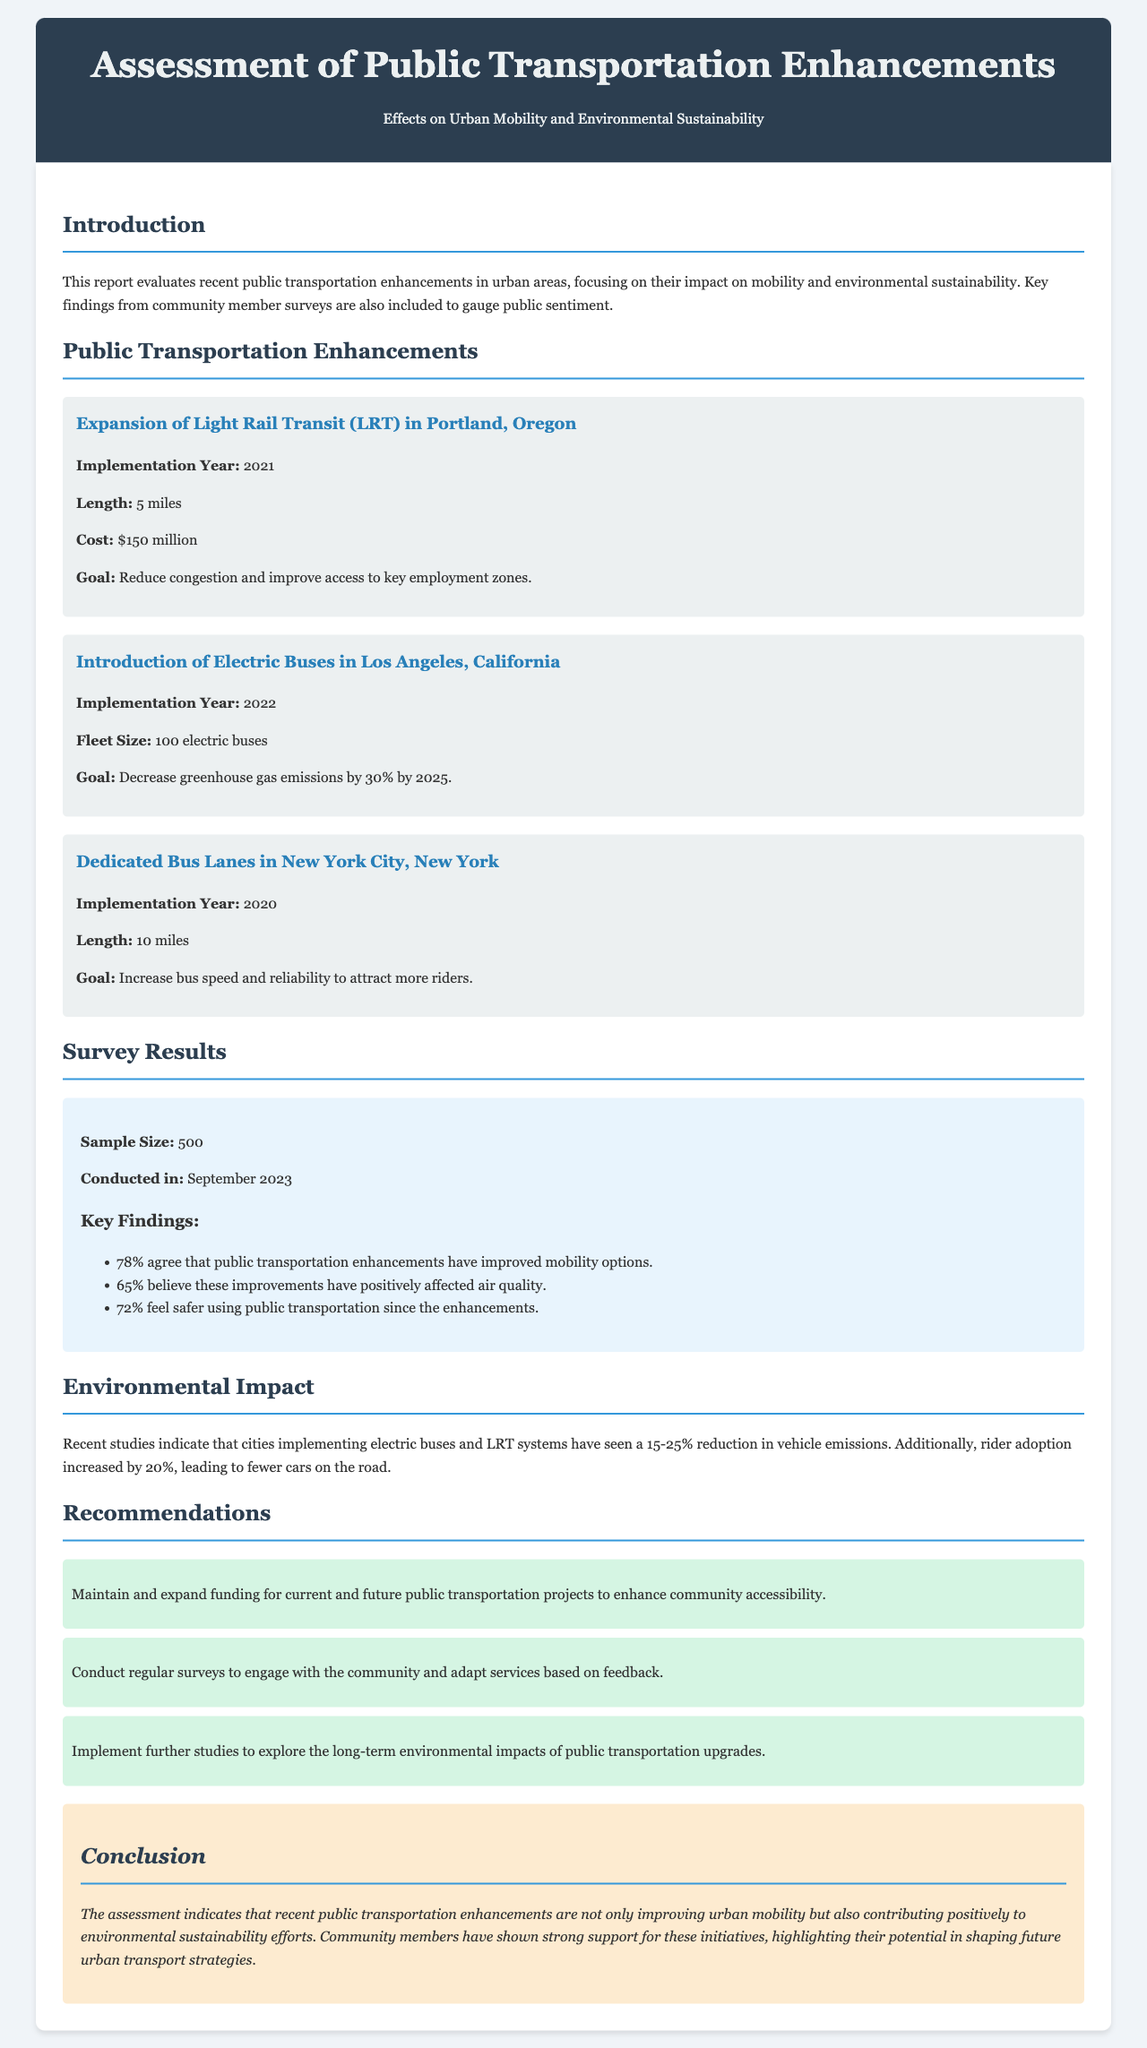What is the implementation year of the Electric Buses in Los Angeles? The implementation year is specifically mentioned in the section about Electric Buses, which states it was implemented in 2022.
Answer: 2022 What percentage of survey respondents agree that public transportation enhancements improved mobility options? The document reports that 78% of surveyed community members agree that public transportation enhancements have improved mobility options.
Answer: 78% What is the goal of the Dedicated Bus Lanes in New York City? The document states the goal of the Dedicated Bus Lanes is to increase bus speed and reliability to attract more riders.
Answer: Increase bus speed and reliability How many electric buses were introduced in Los Angeles? The specific section regarding Electric Buses provides the fleet size, stating 100 electric buses were introduced.
Answer: 100 electric buses What was noted as the community's sentiment towards using public transportation since enhancements? According to the survey results, 72% feel safer using public transportation since the enhancements.
Answer: 72% feel safer What is the estimated reduction in vehicle emissions from implementing electric buses and LRT systems? The document indicates cities implementing these systems have seen a 15-25% reduction in vehicle emissions, providing a range for the estimate.
Answer: 15-25% What is one of the recommendations made in the report? The document provides several recommendations, one of which is to maintain and expand funding for current and future public transportation projects.
Answer: Maintain and expand funding What type of research is suggested to explore the long-term impacts of transportation upgrades? The recommendations section suggests conducting further studies, specifically aimed at exploring long-term environmental impacts.
Answer: Further studies 